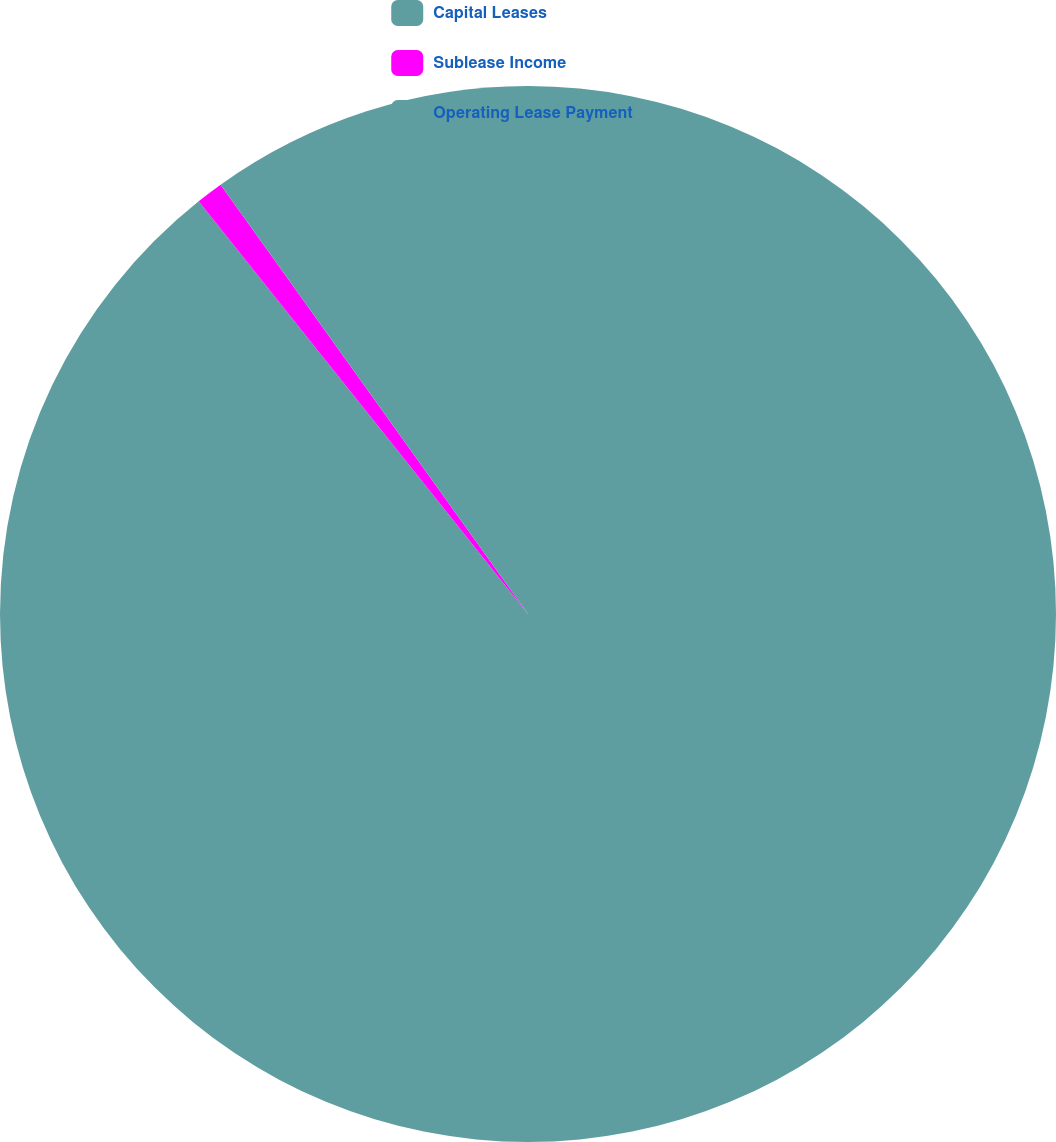Convert chart to OTSL. <chart><loc_0><loc_0><loc_500><loc_500><pie_chart><fcel>Capital Leases<fcel>Sublease Income<fcel>Operating Lease Payment<nl><fcel>89.28%<fcel>0.83%<fcel>9.89%<nl></chart> 